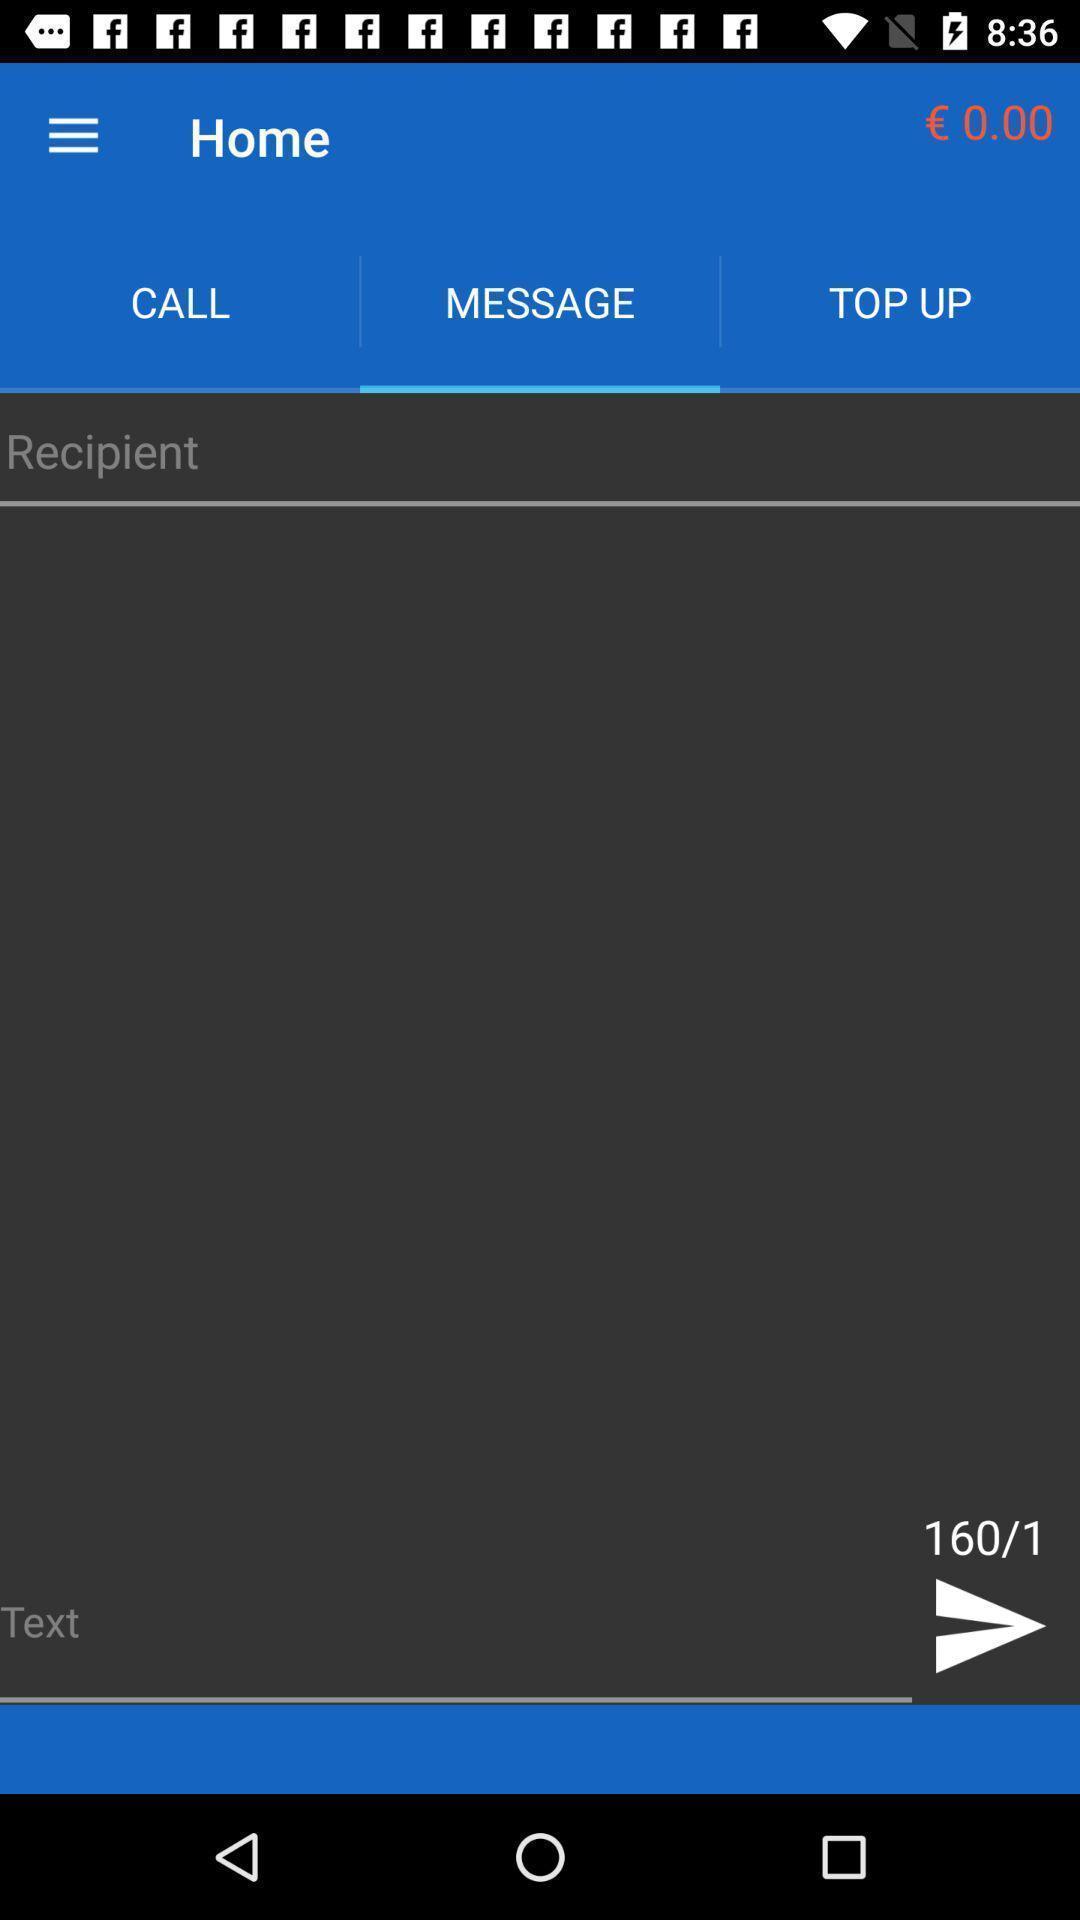Tell me what you see in this picture. Screen showing message page. 